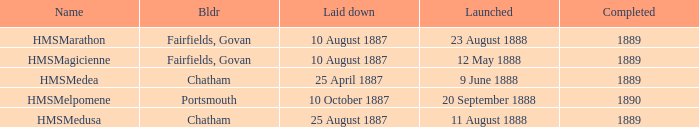What boat was laid down on 25 april 1887? HMSMedea. Parse the full table. {'header': ['Name', 'Bldr', 'Laid down', 'Launched', 'Completed'], 'rows': [['HMSMarathon', 'Fairfields, Govan', '10 August 1887', '23 August 1888', '1889'], ['HMSMagicienne', 'Fairfields, Govan', '10 August 1887', '12 May 1888', '1889'], ['HMSMedea', 'Chatham', '25 April 1887', '9 June 1888', '1889'], ['HMSMelpomene', 'Portsmouth', '10 October 1887', '20 September 1888', '1890'], ['HMSMedusa', 'Chatham', '25 August 1887', '11 August 1888', '1889']]} 